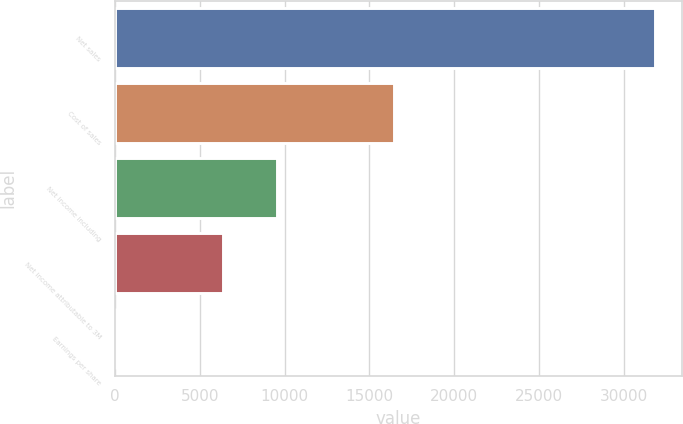Convert chart to OTSL. <chart><loc_0><loc_0><loc_500><loc_500><bar_chart><fcel>Net sales<fcel>Cost of sales<fcel>Net income including<fcel>Net income attributable to 3M<fcel>Earnings per share<nl><fcel>31821<fcel>16447<fcel>9551.54<fcel>6370.19<fcel>7.49<nl></chart> 